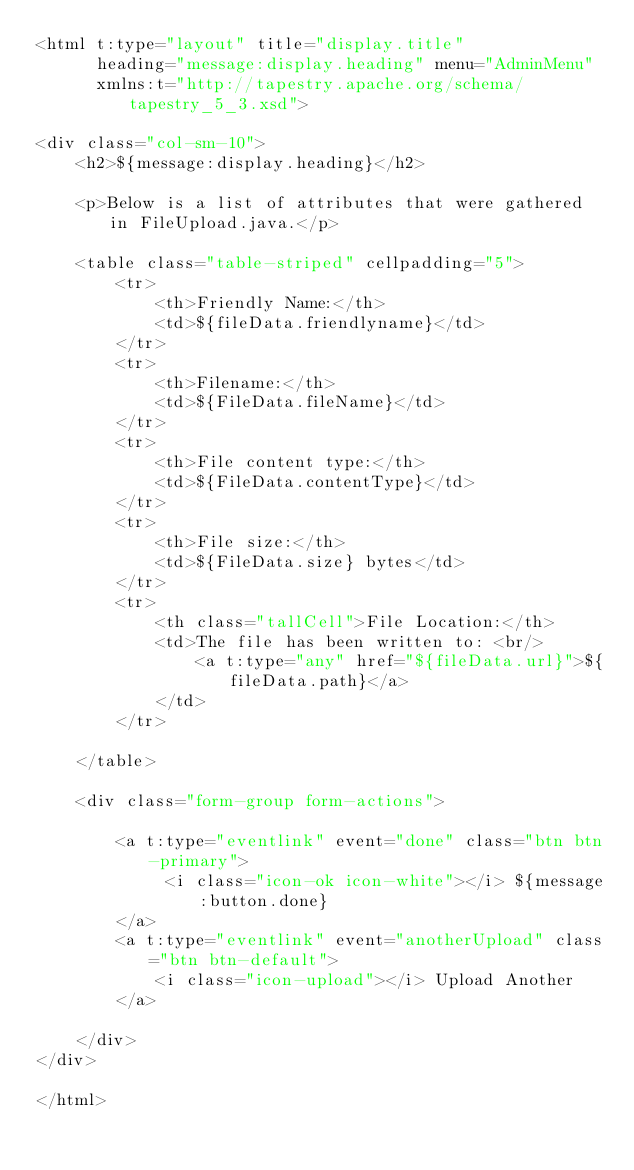Convert code to text. <code><loc_0><loc_0><loc_500><loc_500><_XML_><html t:type="layout" title="display.title"
      heading="message:display.heading" menu="AdminMenu"
      xmlns:t="http://tapestry.apache.org/schema/tapestry_5_3.xsd">

<div class="col-sm-10">
    <h2>${message:display.heading}</h2>

    <p>Below is a list of attributes that were gathered in FileUpload.java.</p>

    <table class="table-striped" cellpadding="5">
        <tr>
            <th>Friendly Name:</th>
            <td>${fileData.friendlyname}</td>
        </tr>
        <tr>
            <th>Filename:</th>
            <td>${FileData.fileName}</td>
        </tr>
        <tr>
            <th>File content type:</th>
            <td>${FileData.contentType}</td>
        </tr>
        <tr>
            <th>File size:</th>
            <td>${FileData.size} bytes</td>
        </tr>
        <tr>
            <th class="tallCell">File Location:</th>
            <td>The file has been written to: <br/>
                <a t:type="any" href="${fileData.url}">${fileData.path}</a>
            </td>
        </tr>

    </table>

    <div class="form-group form-actions">

        <a t:type="eventlink" event="done" class="btn btn-primary">
             <i class="icon-ok icon-white"></i> ${message:button.done}
        </a>
        <a t:type="eventlink" event="anotherUpload" class="btn btn-default">
            <i class="icon-upload"></i> Upload Another
        </a>

    </div>
</div>

</html>
</code> 